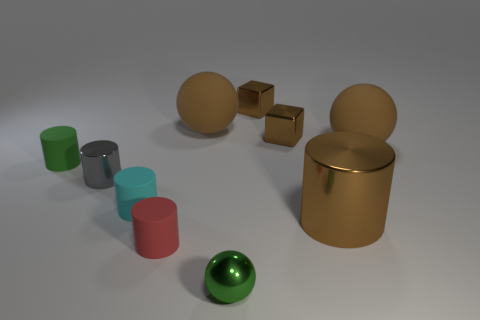What is the size of the cylinder that is the same color as the tiny ball?
Make the answer very short. Small. Does the brown shiny object that is in front of the tiny green rubber cylinder have the same shape as the tiny gray metallic thing?
Make the answer very short. Yes. What material is the big brown thing that is the same shape as the small cyan matte thing?
Your answer should be compact. Metal. How many purple metal cylinders have the same size as the cyan object?
Ensure brevity in your answer.  0. The metal thing that is both in front of the small gray shiny cylinder and behind the red matte thing is what color?
Provide a succinct answer. Brown. Is the number of blocks less than the number of tiny metallic spheres?
Offer a very short reply. No. Does the shiny ball have the same color as the metal cylinder that is right of the small shiny cylinder?
Give a very brief answer. No. Is the number of gray metal cylinders that are left of the brown shiny cylinder the same as the number of metallic cylinders that are on the left side of the tiny red rubber object?
Make the answer very short. Yes. How many green objects have the same shape as the red rubber thing?
Your response must be concise. 1. Are any small brown metallic cubes visible?
Offer a very short reply. Yes. 